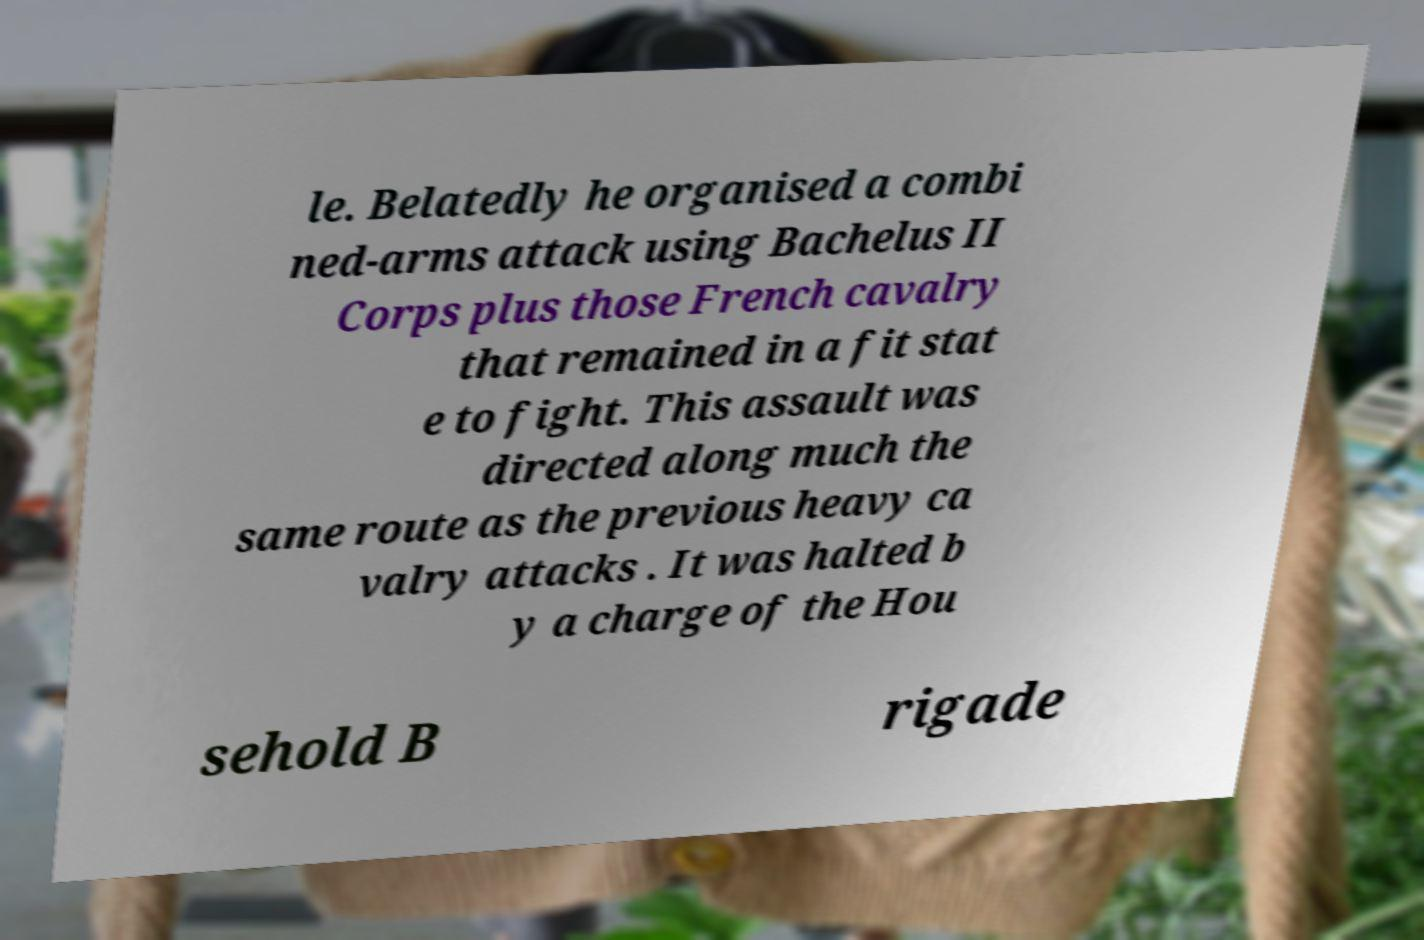For documentation purposes, I need the text within this image transcribed. Could you provide that? le. Belatedly he organised a combi ned-arms attack using Bachelus II Corps plus those French cavalry that remained in a fit stat e to fight. This assault was directed along much the same route as the previous heavy ca valry attacks . It was halted b y a charge of the Hou sehold B rigade 